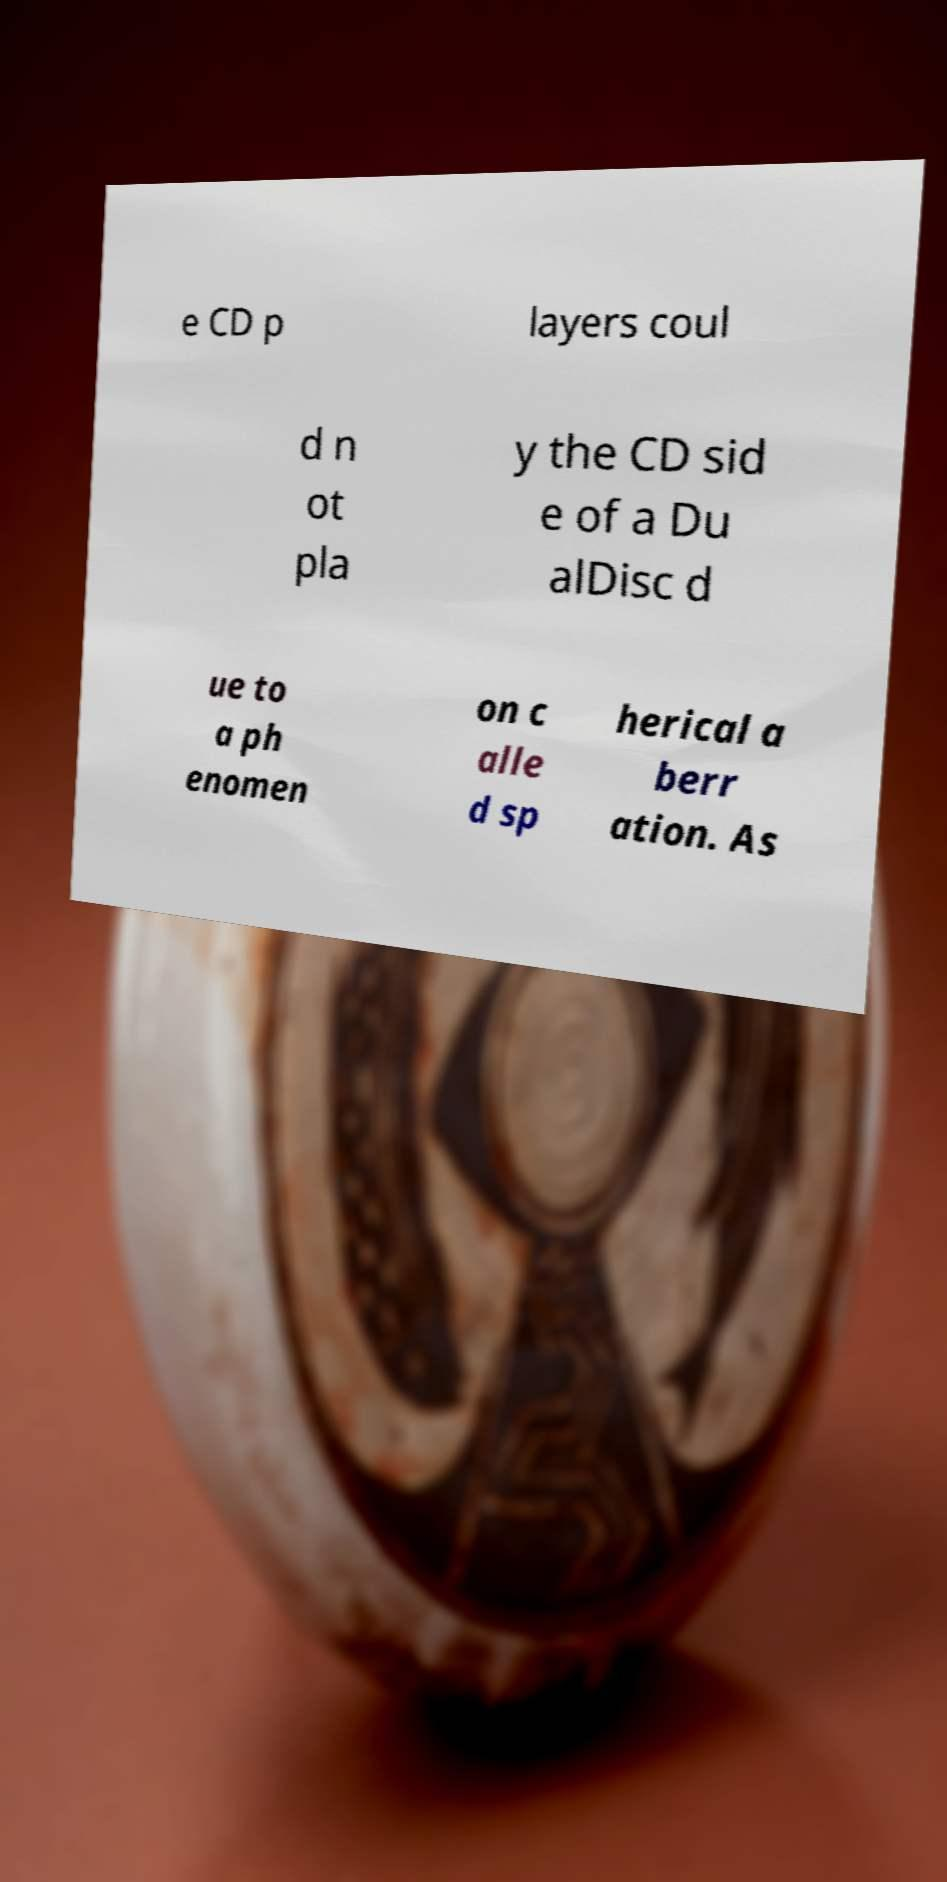I need the written content from this picture converted into text. Can you do that? e CD p layers coul d n ot pla y the CD sid e of a Du alDisc d ue to a ph enomen on c alle d sp herical a berr ation. As 